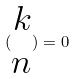<formula> <loc_0><loc_0><loc_500><loc_500>( \begin{matrix} k \\ n \end{matrix} ) = 0</formula> 